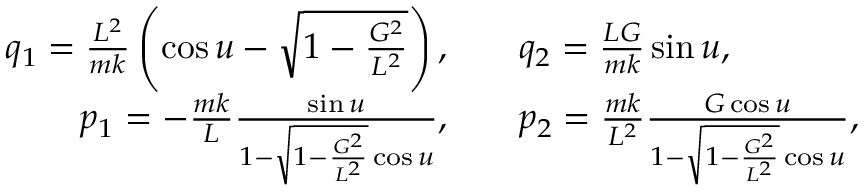Convert formula to latex. <formula><loc_0><loc_0><loc_500><loc_500>\begin{array} { r l } { q _ { 1 } = \frac { L ^ { 2 } } { m k } \left ( \cos u - \sqrt { 1 - \frac { G ^ { 2 } } { L ^ { 2 } } } \right ) , \quad } & { q _ { 2 } = \frac { L G } { m k } \sin u , } \\ { p _ { 1 } = - \frac { m k } { L } \frac { \sin u } { 1 - \sqrt { 1 - \frac { G ^ { 2 } } { L ^ { 2 } } } \cos u } , \quad } & { p _ { 2 } = \frac { m k } { L ^ { 2 } } \frac { G \cos u } { 1 - \sqrt { 1 - \frac { G ^ { 2 } } { L ^ { 2 } } } \cos u } , } \end{array}</formula> 